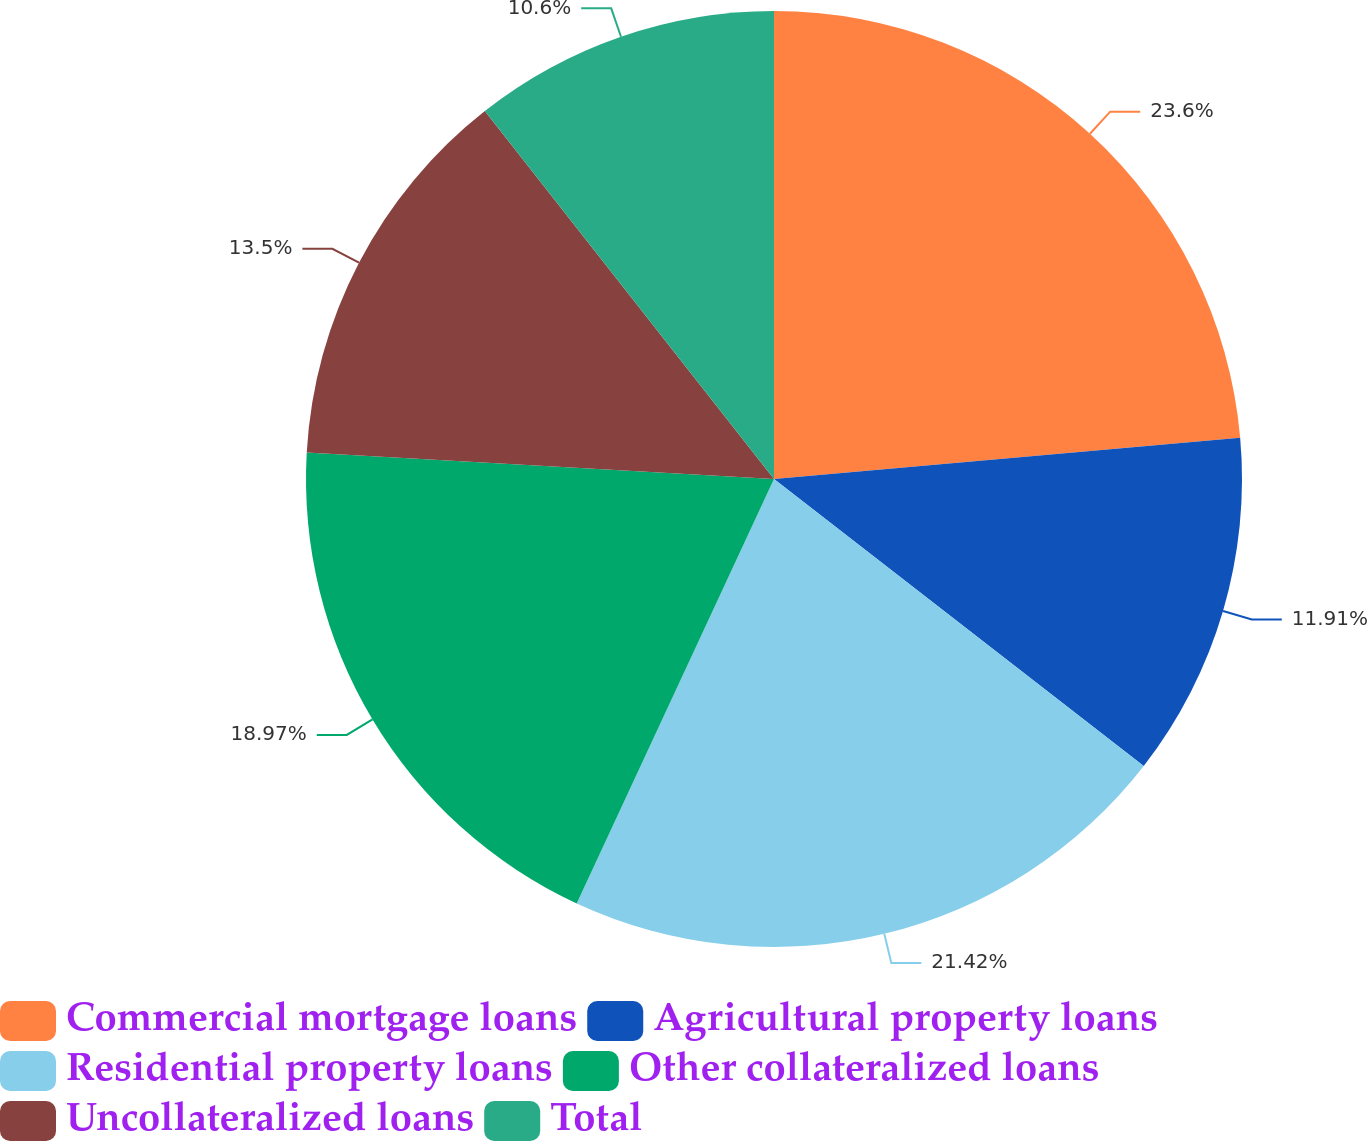Convert chart to OTSL. <chart><loc_0><loc_0><loc_500><loc_500><pie_chart><fcel>Commercial mortgage loans<fcel>Agricultural property loans<fcel>Residential property loans<fcel>Other collateralized loans<fcel>Uncollateralized loans<fcel>Total<nl><fcel>23.59%<fcel>11.91%<fcel>21.42%<fcel>18.97%<fcel>13.5%<fcel>10.6%<nl></chart> 